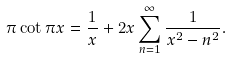Convert formula to latex. <formula><loc_0><loc_0><loc_500><loc_500>\pi \cot \pi x = { \frac { 1 } { x } } + 2 x \sum _ { n = 1 } ^ { \infty } { \frac { 1 } { x ^ { 2 } - n ^ { 2 } } } .</formula> 